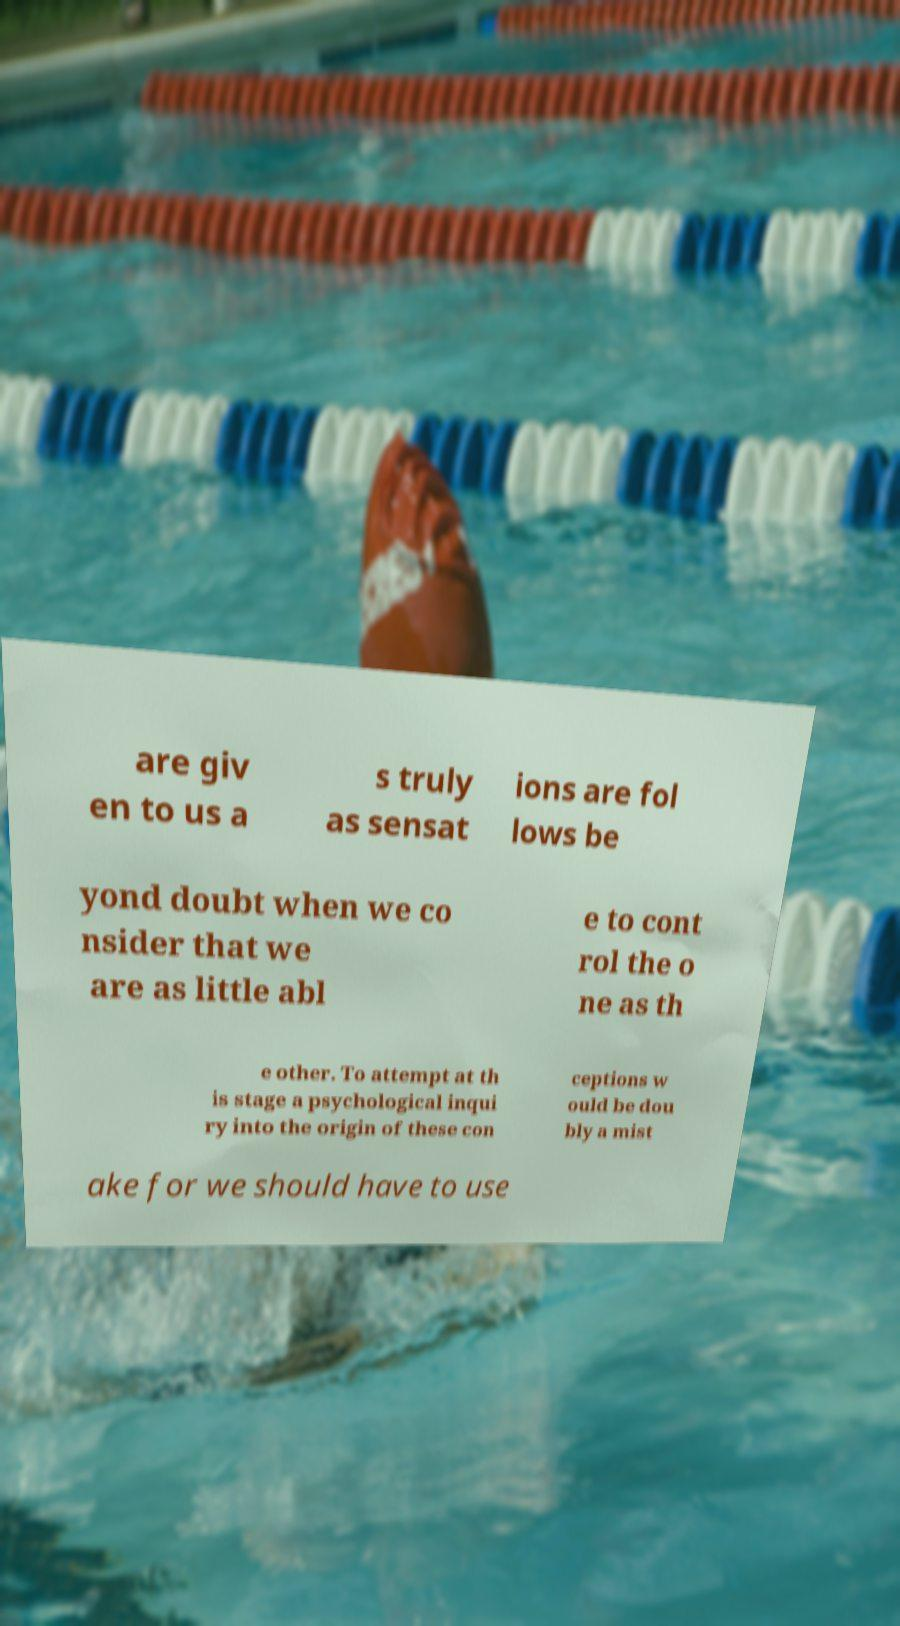For documentation purposes, I need the text within this image transcribed. Could you provide that? are giv en to us a s truly as sensat ions are fol lows be yond doubt when we co nsider that we are as little abl e to cont rol the o ne as th e other. To attempt at th is stage a psychological inqui ry into the origin of these con ceptions w ould be dou bly a mist ake for we should have to use 